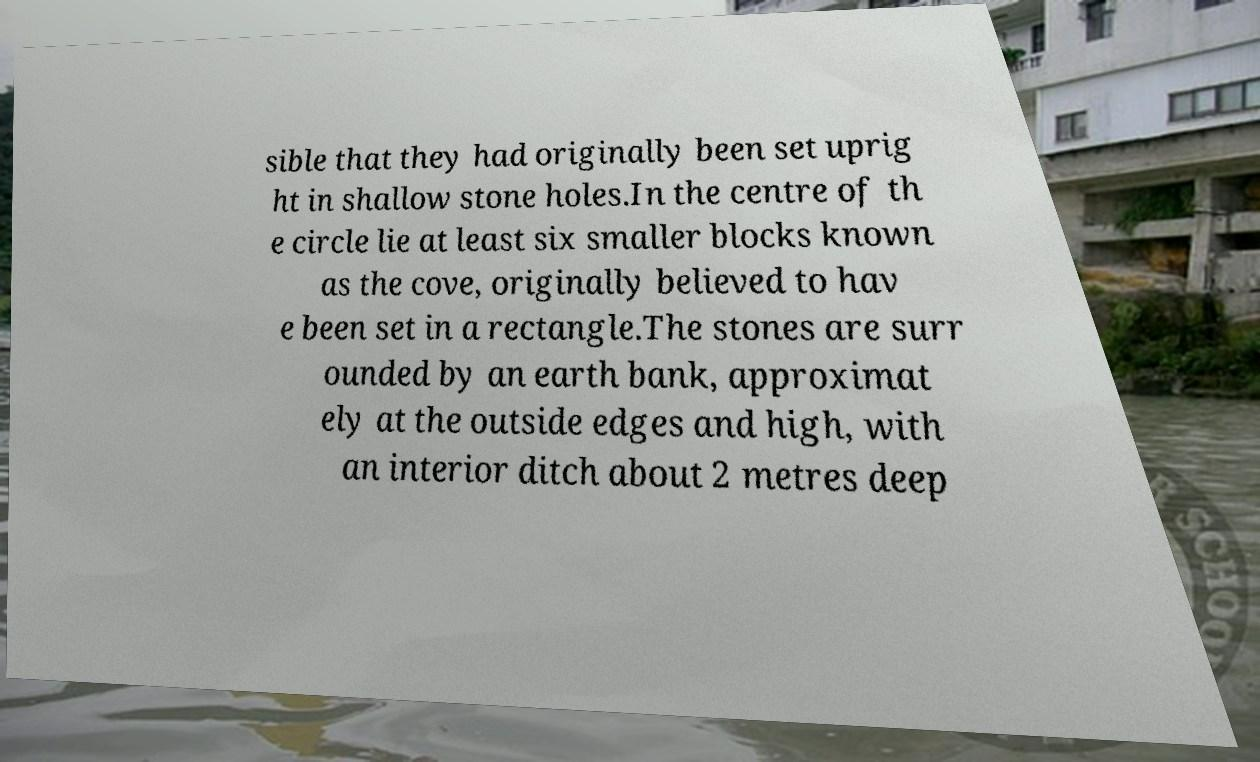Please identify and transcribe the text found in this image. sible that they had originally been set uprig ht in shallow stone holes.In the centre of th e circle lie at least six smaller blocks known as the cove, originally believed to hav e been set in a rectangle.The stones are surr ounded by an earth bank, approximat ely at the outside edges and high, with an interior ditch about 2 metres deep 